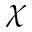<formula> <loc_0><loc_0><loc_500><loc_500>\chi</formula> 